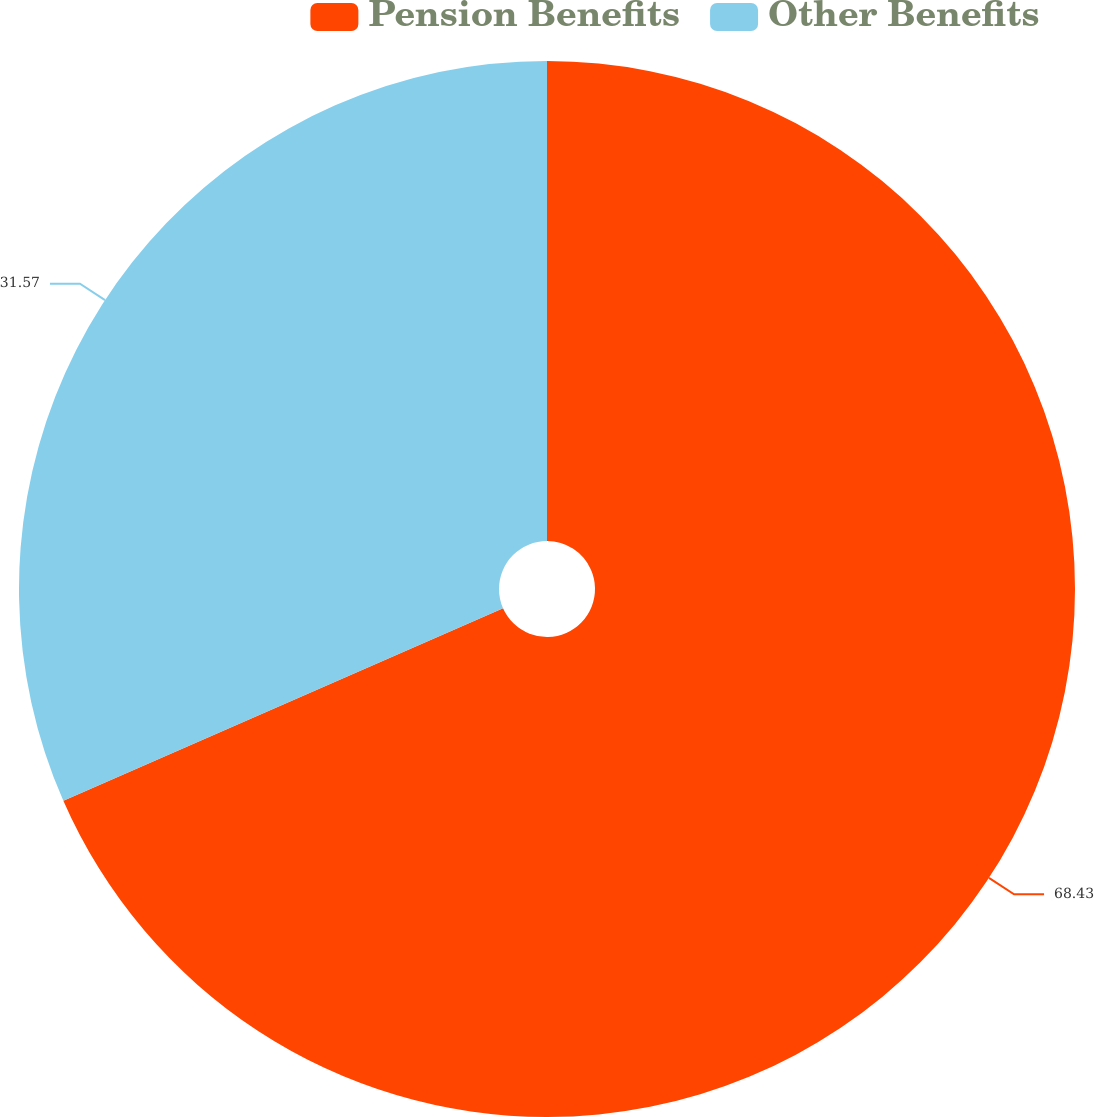Convert chart to OTSL. <chart><loc_0><loc_0><loc_500><loc_500><pie_chart><fcel>Pension Benefits<fcel>Other Benefits<nl><fcel>68.43%<fcel>31.57%<nl></chart> 